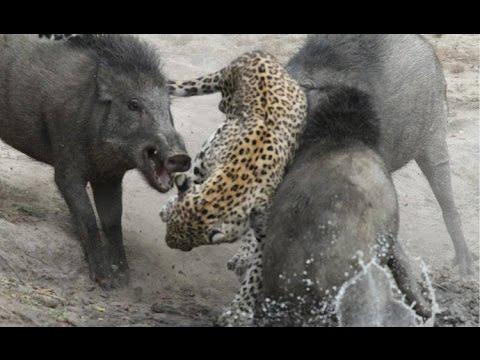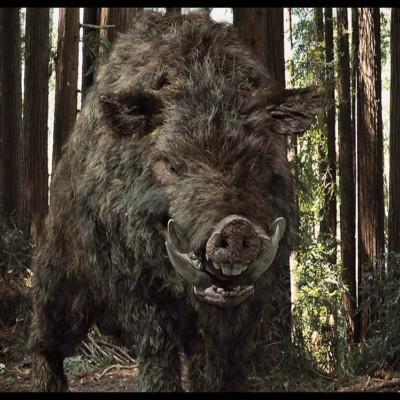The first image is the image on the left, the second image is the image on the right. For the images displayed, is the sentence "There is more than one animal species in the image." factually correct? Answer yes or no. Yes. The first image is the image on the left, the second image is the image on the right. For the images displayed, is the sentence "The left image contains exactly one wild boar." factually correct? Answer yes or no. No. 